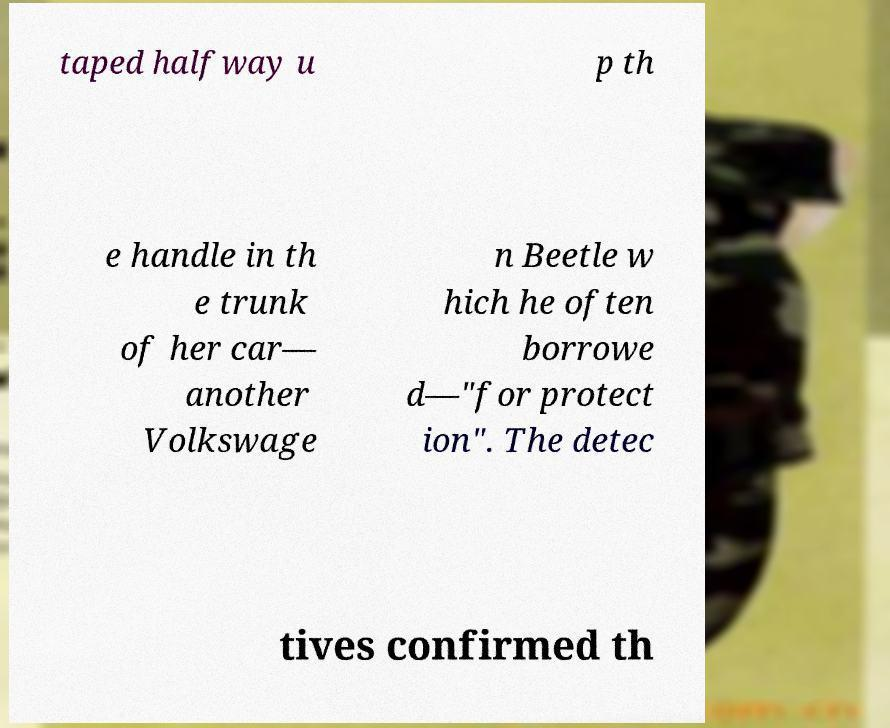Can you read and provide the text displayed in the image?This photo seems to have some interesting text. Can you extract and type it out for me? taped halfway u p th e handle in th e trunk of her car— another Volkswage n Beetle w hich he often borrowe d—"for protect ion". The detec tives confirmed th 